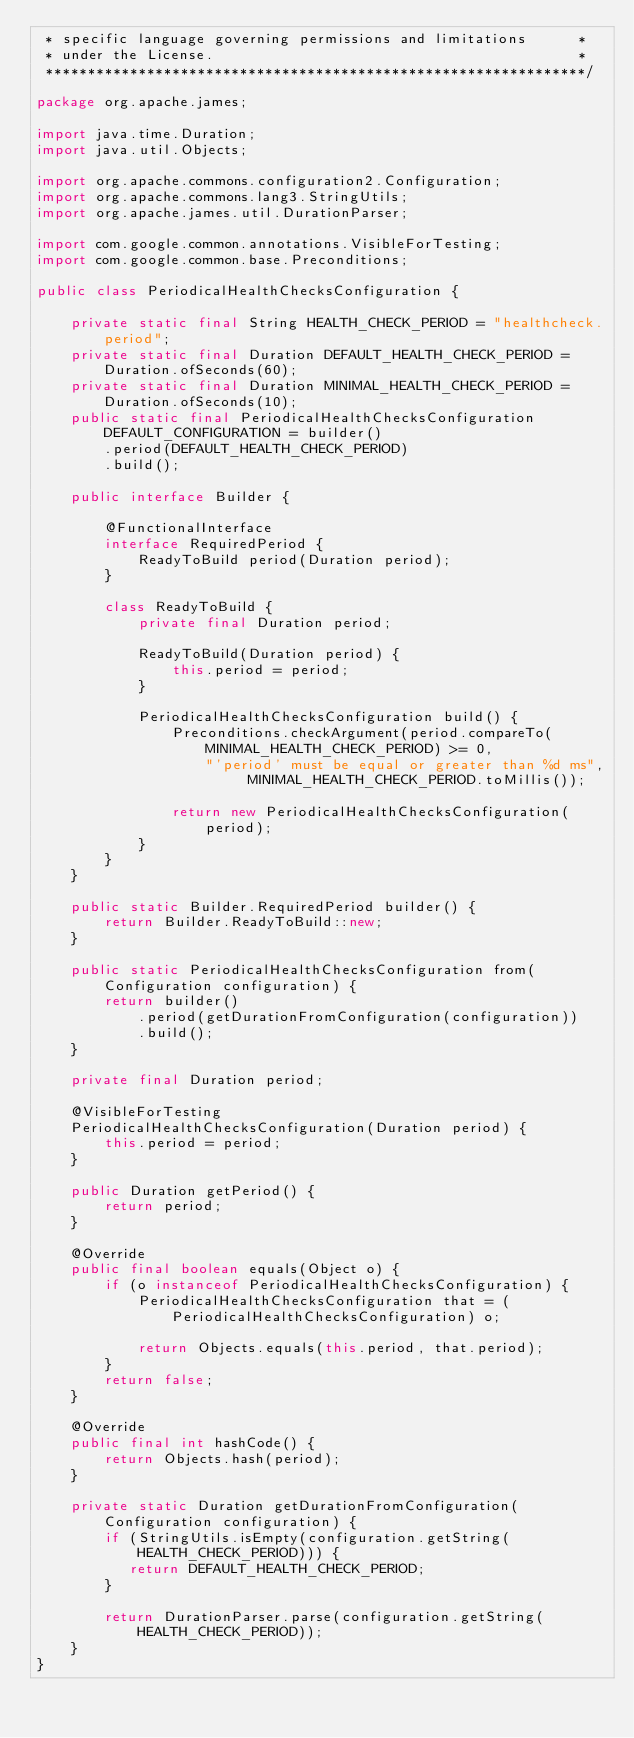Convert code to text. <code><loc_0><loc_0><loc_500><loc_500><_Java_> * specific language governing permissions and limitations      *
 * under the License.                                           *
 ****************************************************************/

package org.apache.james;

import java.time.Duration;
import java.util.Objects;

import org.apache.commons.configuration2.Configuration;
import org.apache.commons.lang3.StringUtils;
import org.apache.james.util.DurationParser;

import com.google.common.annotations.VisibleForTesting;
import com.google.common.base.Preconditions;

public class PeriodicalHealthChecksConfiguration {

    private static final String HEALTH_CHECK_PERIOD = "healthcheck.period";
    private static final Duration DEFAULT_HEALTH_CHECK_PERIOD = Duration.ofSeconds(60);
    private static final Duration MINIMAL_HEALTH_CHECK_PERIOD = Duration.ofSeconds(10);
    public static final PeriodicalHealthChecksConfiguration DEFAULT_CONFIGURATION = builder()
        .period(DEFAULT_HEALTH_CHECK_PERIOD)
        .build();

    public interface Builder {

        @FunctionalInterface
        interface RequiredPeriod {
            ReadyToBuild period(Duration period);
        }

        class ReadyToBuild {
            private final Duration period;

            ReadyToBuild(Duration period) {
                this.period = period;
            }

            PeriodicalHealthChecksConfiguration build() {
                Preconditions.checkArgument(period.compareTo(MINIMAL_HEALTH_CHECK_PERIOD) >= 0,
                    "'period' must be equal or greater than %d ms", MINIMAL_HEALTH_CHECK_PERIOD.toMillis());

                return new PeriodicalHealthChecksConfiguration(period);
            }
        }
    }

    public static Builder.RequiredPeriod builder() {
        return Builder.ReadyToBuild::new;
    }

    public static PeriodicalHealthChecksConfiguration from(Configuration configuration) {
        return builder()
            .period(getDurationFromConfiguration(configuration))
            .build();
    }

    private final Duration period;

    @VisibleForTesting
    PeriodicalHealthChecksConfiguration(Duration period) {
        this.period = period;
    }

    public Duration getPeriod() {
        return period;
    }

    @Override
    public final boolean equals(Object o) {
        if (o instanceof PeriodicalHealthChecksConfiguration) {
            PeriodicalHealthChecksConfiguration that = (PeriodicalHealthChecksConfiguration) o;

            return Objects.equals(this.period, that.period);
        }
        return false;
    }

    @Override
    public final int hashCode() {
        return Objects.hash(period);
    }

    private static Duration getDurationFromConfiguration(Configuration configuration) {
        if (StringUtils.isEmpty(configuration.getString(HEALTH_CHECK_PERIOD))) {
           return DEFAULT_HEALTH_CHECK_PERIOD;
        }

        return DurationParser.parse(configuration.getString(HEALTH_CHECK_PERIOD));
    }
}</code> 